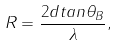Convert formula to latex. <formula><loc_0><loc_0><loc_500><loc_500>R = \frac { 2 d t a n \theta _ { B } } { \lambda } ,</formula> 